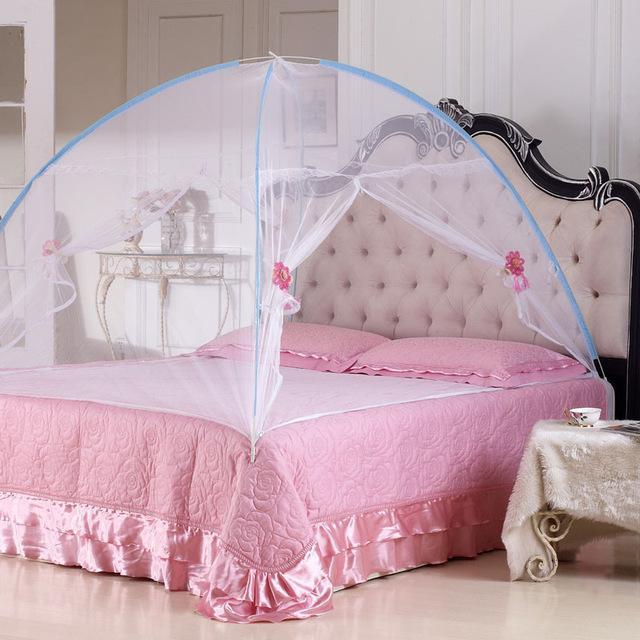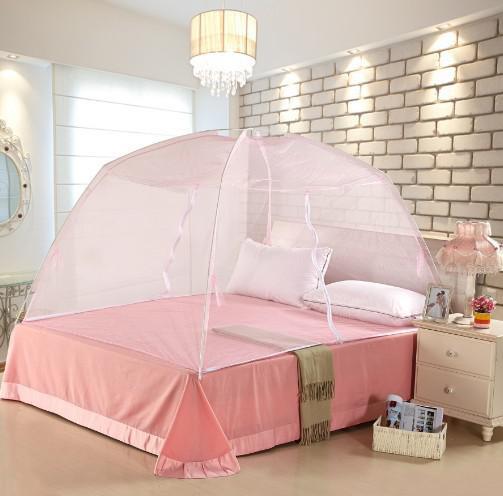The first image is the image on the left, the second image is the image on the right. Assess this claim about the two images: "The bed on the left has a canopy that ties at the middle of the four posts, and the bed on the right has a pale canopy that creates a square shape but does not tie at the corners.". Correct or not? Answer yes or no. No. The first image is the image on the left, the second image is the image on the right. Evaluate the accuracy of this statement regarding the images: "The left and right image contains the same number of square lace canopies.". Is it true? Answer yes or no. No. 